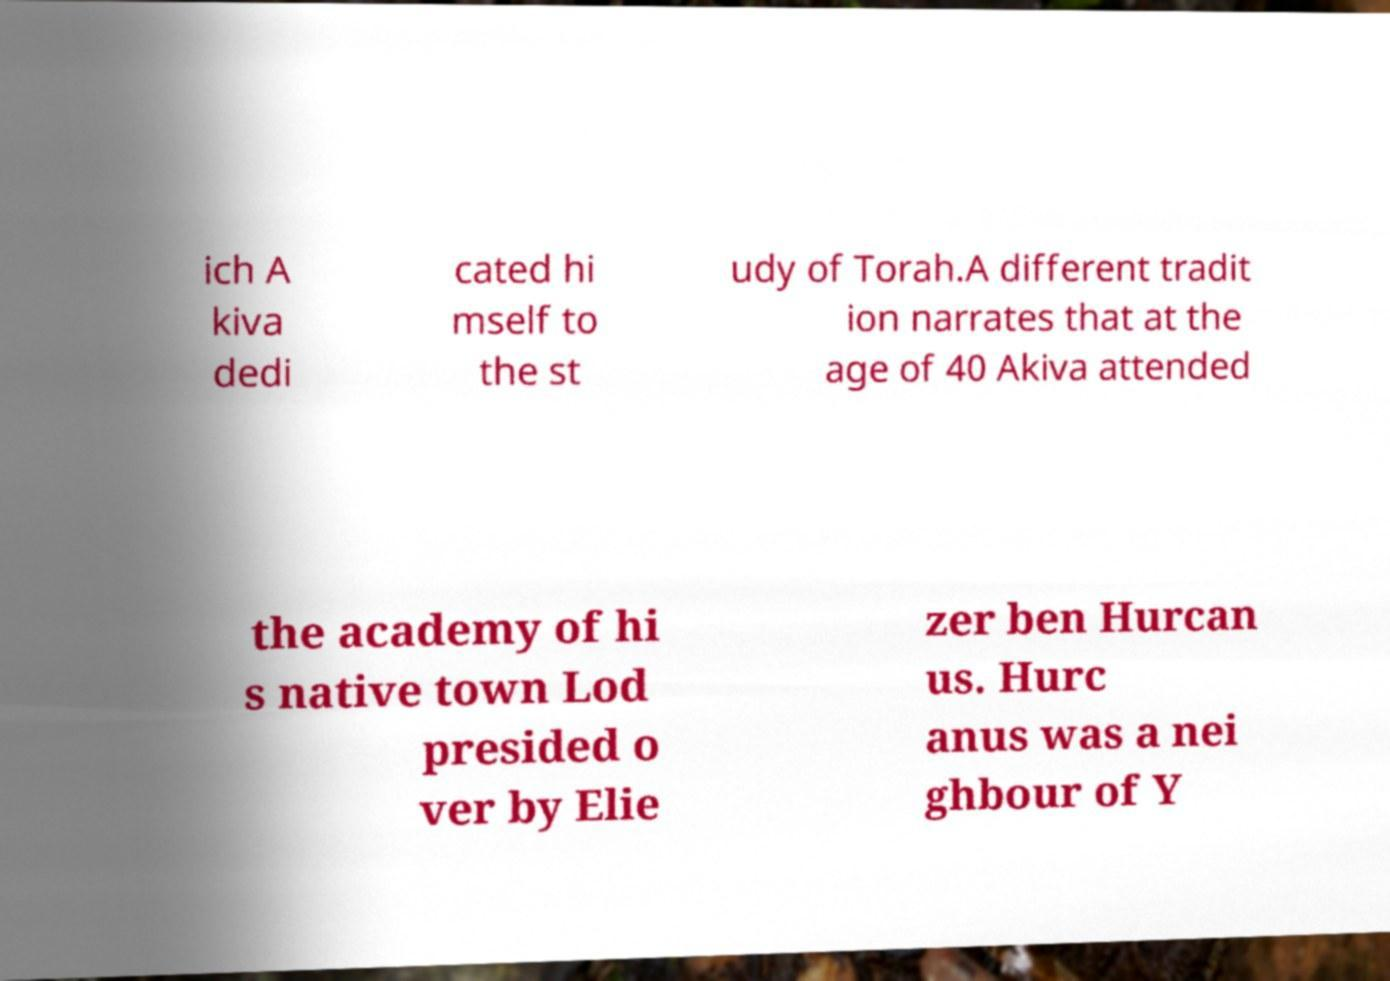I need the written content from this picture converted into text. Can you do that? ich A kiva dedi cated hi mself to the st udy of Torah.A different tradit ion narrates that at the age of 40 Akiva attended the academy of hi s native town Lod presided o ver by Elie zer ben Hurcan us. Hurc anus was a nei ghbour of Y 